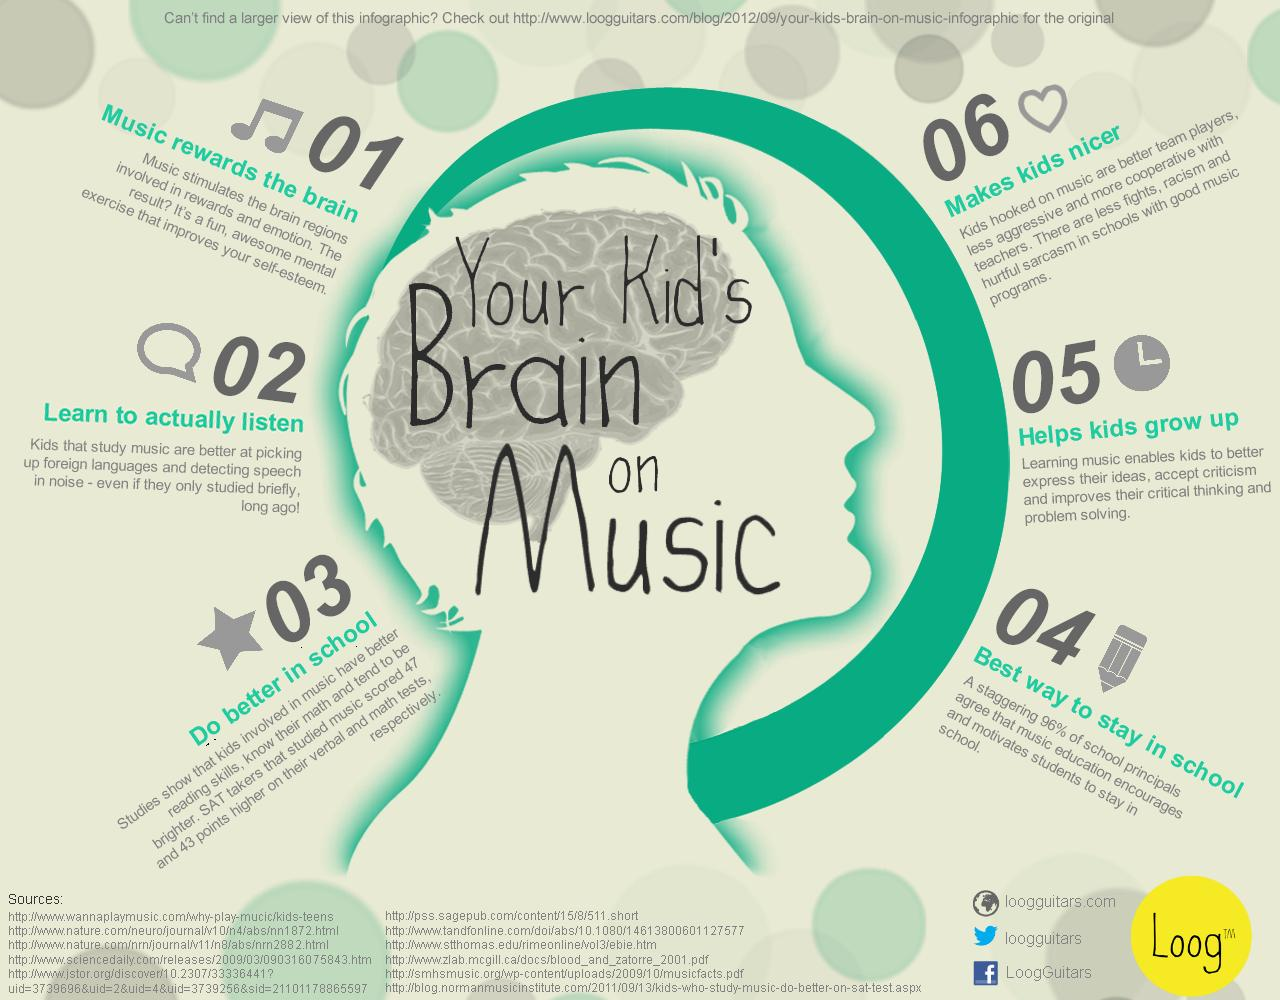Identify some key points in this picture. SAT takers who were involved in music scored an average of 47 and 43 points higher in the verbal and math tests, respectively, compared to those who did not participate in music. Music education has been shown to be a powerful motivator for students to stay in school. Learning music has been proven to improve critical thinking and problem-solving skills, as per the fifth point. Music makes it easier for students to pick up foreign languages. According to the first point, music has been found to improve self-esteem. 